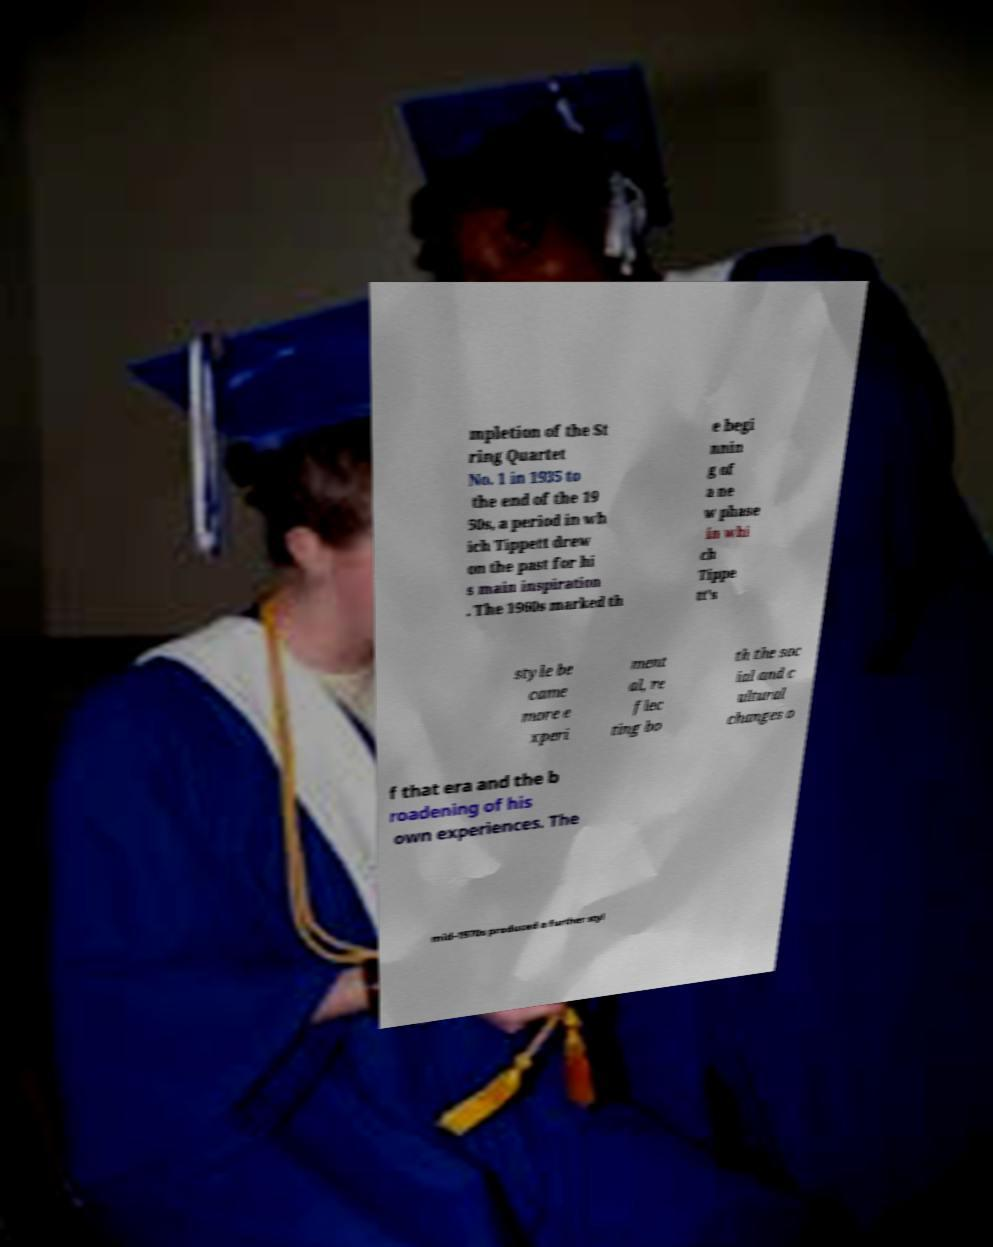Please read and relay the text visible in this image. What does it say? mpletion of the St ring Quartet No. 1 in 1935 to the end of the 19 50s, a period in wh ich Tippett drew on the past for hi s main inspiration . The 1960s marked th e begi nnin g of a ne w phase in whi ch Tippe tt's style be came more e xperi ment al, re flec ting bo th the soc ial and c ultural changes o f that era and the b roadening of his own experiences. The mid-1970s produced a further styl 